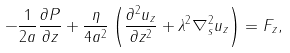Convert formula to latex. <formula><loc_0><loc_0><loc_500><loc_500>- \frac { 1 } { 2 a } \frac { \partial P } { \partial z } + \frac { \eta } { 4 a ^ { 2 } } \left ( \frac { \partial ^ { 2 } u _ { z } } { \partial z ^ { 2 } } + \lambda ^ { 2 } \nabla _ { s } ^ { 2 } u _ { z } \right ) = F _ { z } ,</formula> 